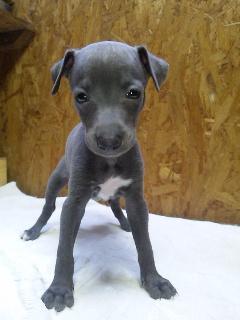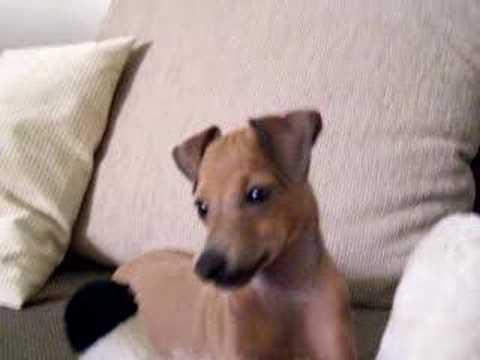The first image is the image on the left, the second image is the image on the right. Analyze the images presented: Is the assertion "Left and right images each contain one similarly posed and sized dog." valid? Answer yes or no. No. The first image is the image on the left, the second image is the image on the right. Given the left and right images, does the statement "At least one image shows a single dog standing up with only paws touching the ground." hold true? Answer yes or no. Yes. 